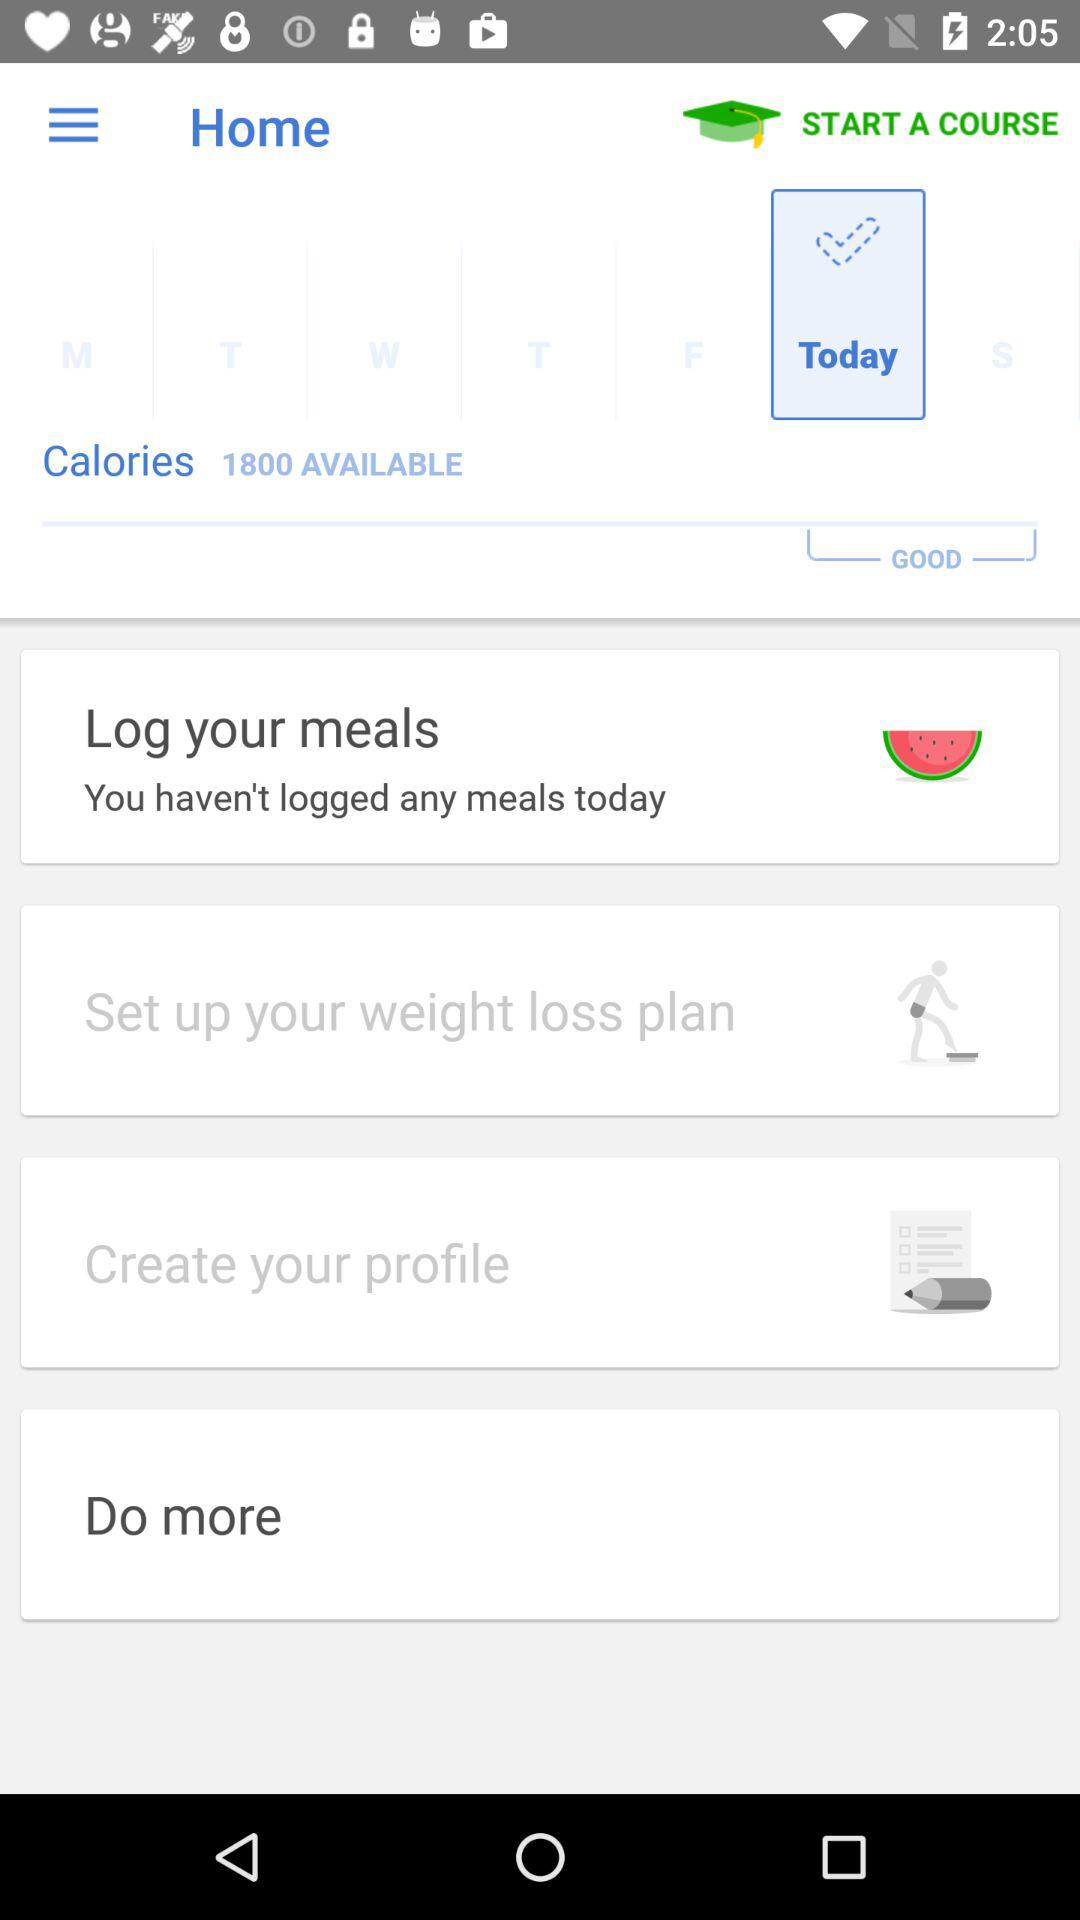How many calories are available to log?
Answer the question using a single word or phrase. 1800 